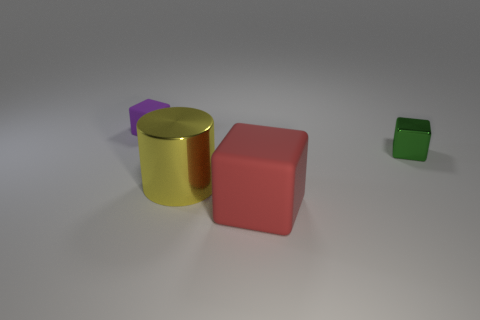What number of rubber things are small purple balls or yellow things?
Keep it short and to the point. 0. How many purple rubber objects have the same size as the green metallic object?
Your answer should be very brief. 1. There is a thing that is behind the red block and to the right of the big yellow shiny cylinder; what is its color?
Your answer should be compact. Green. What number of things are either small green shiny objects or purple matte blocks?
Provide a short and direct response. 2. How many large things are metal cylinders or shiny cubes?
Provide a short and direct response. 1. Is there any other thing of the same color as the large rubber object?
Your answer should be very brief. No. There is a block that is behind the red block and on the left side of the green metallic cube; what is its size?
Offer a terse response. Small. What number of other things are the same material as the tiny green thing?
Keep it short and to the point. 1. There is a thing that is both behind the red object and to the right of the yellow object; what is its shape?
Offer a very short reply. Cube. There is a metal object that is right of the red object; is it the same size as the large matte thing?
Ensure brevity in your answer.  No. 